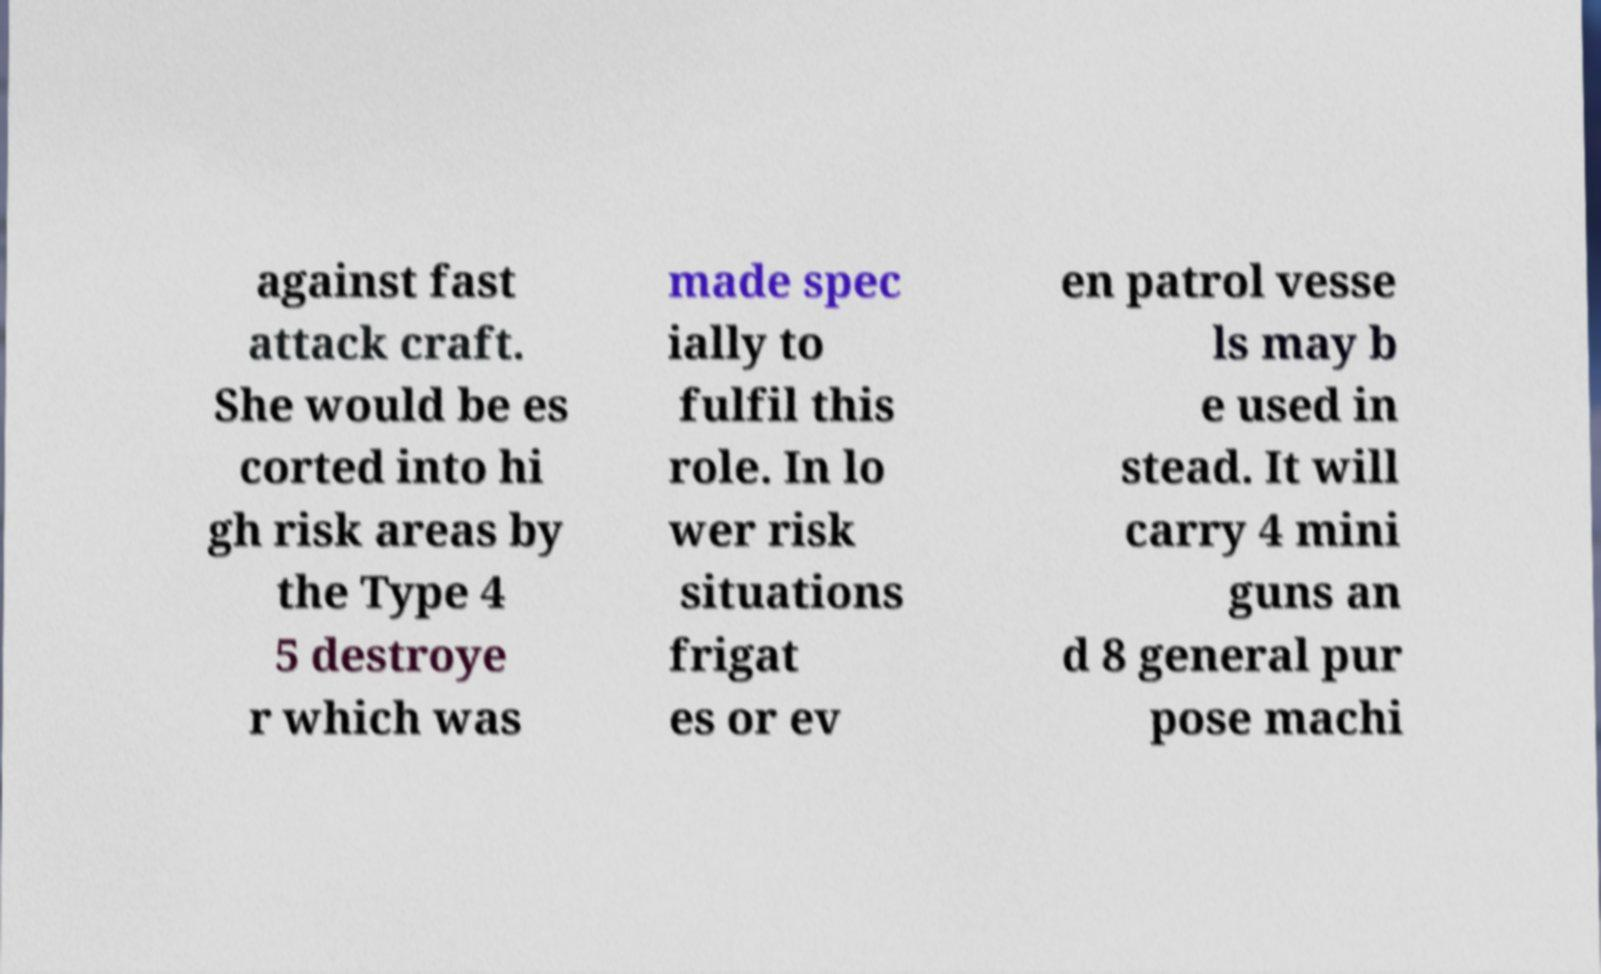I need the written content from this picture converted into text. Can you do that? against fast attack craft. She would be es corted into hi gh risk areas by the Type 4 5 destroye r which was made spec ially to fulfil this role. In lo wer risk situations frigat es or ev en patrol vesse ls may b e used in stead. It will carry 4 mini guns an d 8 general pur pose machi 